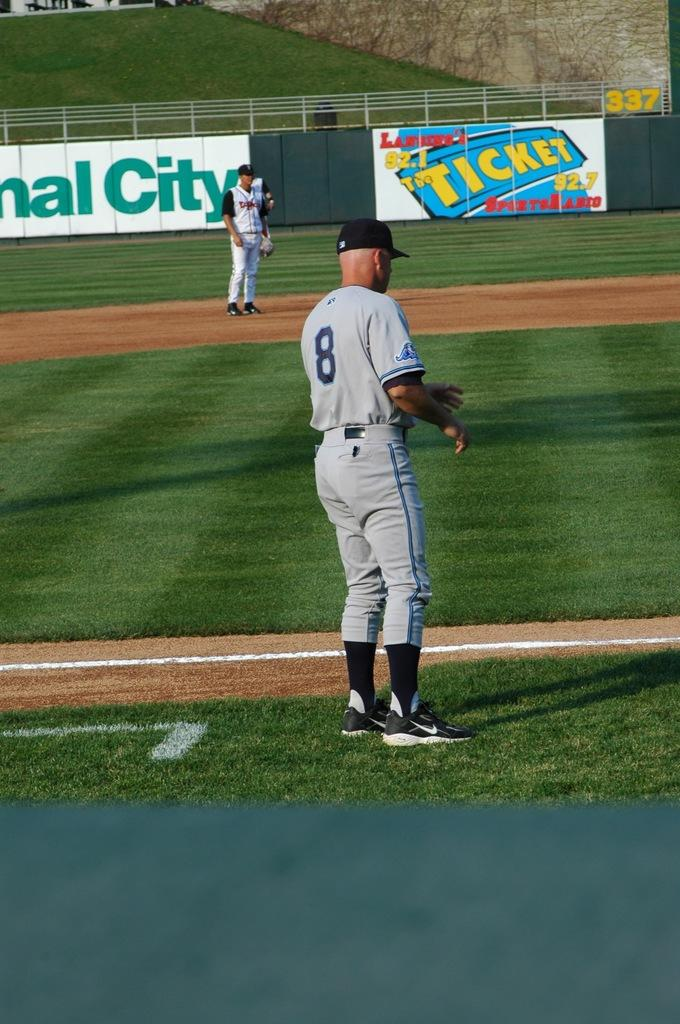What is the main setting of the image? There is a playground in the image. How many players are visible in the image? Two players are standing in the image. What color are the dresses worn by the players? The players are wearing white-colored dresses. What is located behind the players in the image? There is fencing behind the players. What type of pen can be seen in the image? There is no pen present in the image. 